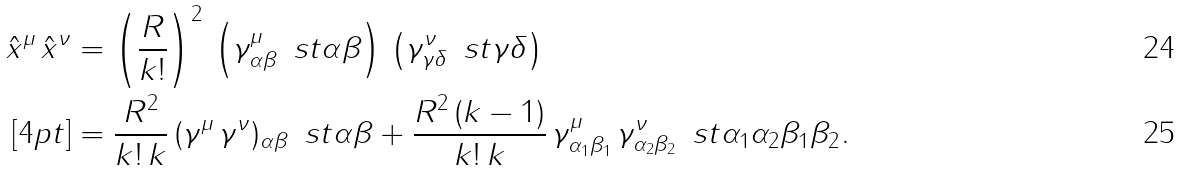Convert formula to latex. <formula><loc_0><loc_0><loc_500><loc_500>\hat { x } ^ { \mu } \, \hat { x } ^ { \nu } & = \left ( \frac { R } { k ! } \right ) ^ { 2 } \, \left ( \gamma ^ { \mu } _ { \alpha \beta } \, \ s t { \alpha } { \beta } \right ) \, \left ( \gamma ^ { \nu } _ { \gamma \delta } \, \ s t { \gamma } { \delta } \right ) \\ [ 4 p t ] & = \frac { R ^ { 2 } } { k ! \, k } \, ( \gamma ^ { \mu } \, \gamma ^ { \nu } ) _ { \alpha \beta } \, \ s t { \alpha } { \beta } + \frac { R ^ { 2 } \, ( k - 1 ) } { k ! \, k } \, \gamma ^ { \mu } _ { \alpha _ { 1 } \beta _ { 1 } } \, \gamma ^ { \nu } _ { \alpha _ { 2 } \beta _ { 2 } } \, \ s t { \alpha _ { 1 } \alpha _ { 2 } } { \beta _ { 1 } \beta _ { 2 } } .</formula> 